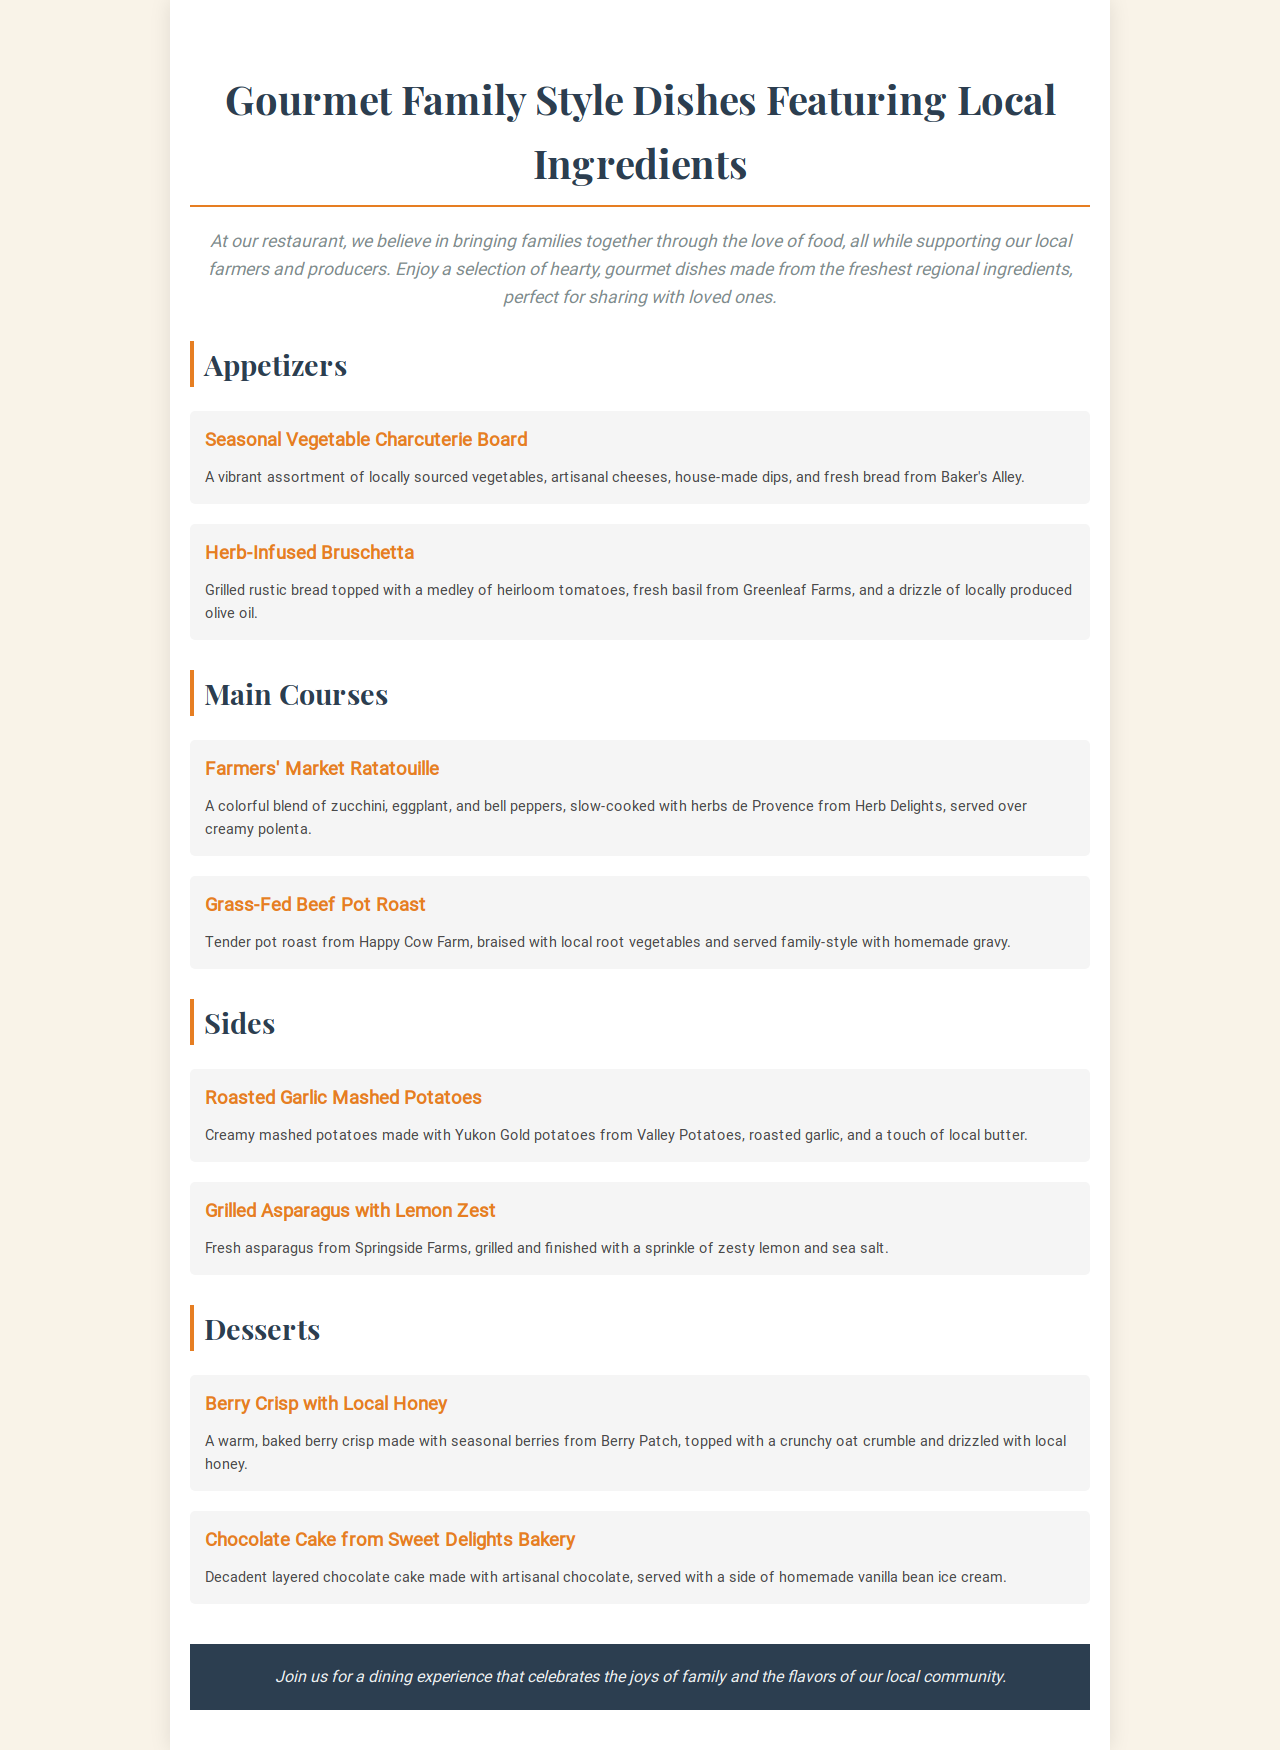what is the title of the document? The title of the document is indicated in the <h1> tag at the top of the menu.
Answer: Gourmet Family Style Dishes Featuring Local Ingredients what is included in the Seasonal Vegetable Charcuterie Board? The description of the Seasonal Vegetable Charcuterie Board lists its components.
Answer: Locally sourced vegetables, artisanal cheeses, house-made dips, and fresh bread from Baker's Alley which farm provides the herbs for the Farmers' Market Ratatouille? The source of the herbs in the dish is mentioned in the description of the Farmers' Market Ratatouille.
Answer: Herb Delights how many main courses are listed on the menu? Counting the items in the Main Courses section of the menu gives the total number of main courses.
Answer: 2 what is the unique ingredient in the Roasted Garlic Mashed Potatoes? The unique ingredient, besides potatoes, is noted in the description of the dish.
Answer: Roasted garlic which dessert features local honey? The dessert that explicitly mentions the use of local honey can be found in the Desserts section.
Answer: Berry Crisp with Local Honey what type of oil is used in the Herb-Infused Bruschetta? The type of oil used is specified in the description of the Herb-Infused Bruschetta.
Answer: Locally produced olive oil who provides the chocolate for the Chocolate Cake? The source of the chocolate for the cake is detailed in the description of the dessert.
Answer: Sweet Delights Bakery what is the intended dining experience presented in the document? The introductory paragraph describes the desired experience for diners.
Answer: A dining experience that celebrates the joys of family and the flavors of our local community 